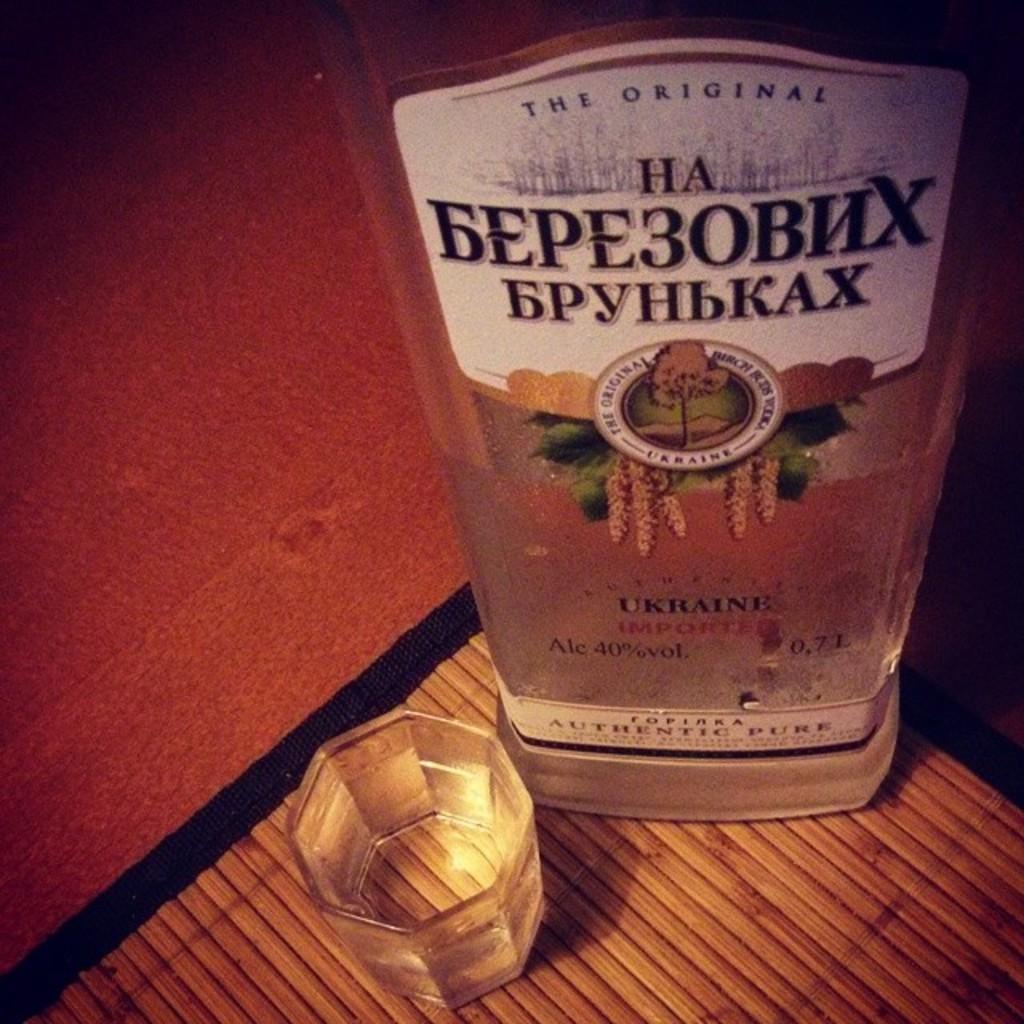What country is this drink from?
Provide a short and direct response. Ukraine. Is this drink an original?
Your answer should be compact. Yes. 